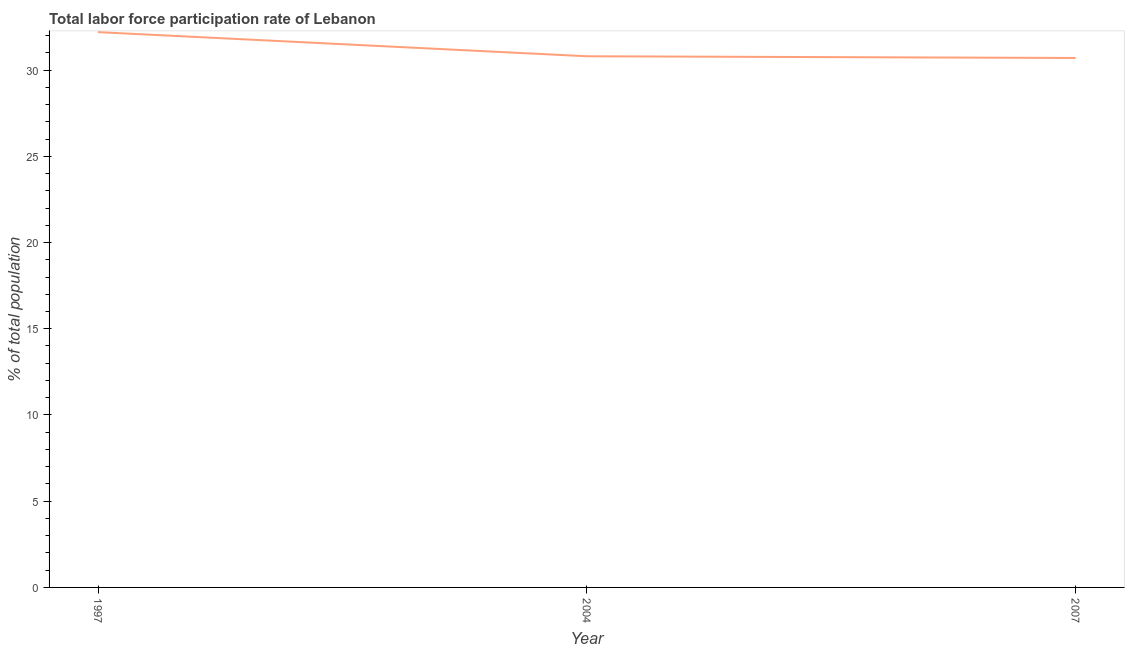What is the total labor force participation rate in 1997?
Provide a short and direct response. 32.2. Across all years, what is the maximum total labor force participation rate?
Your answer should be compact. 32.2. Across all years, what is the minimum total labor force participation rate?
Give a very brief answer. 30.7. In which year was the total labor force participation rate maximum?
Give a very brief answer. 1997. What is the sum of the total labor force participation rate?
Provide a succinct answer. 93.7. What is the difference between the total labor force participation rate in 2004 and 2007?
Make the answer very short. 0.1. What is the average total labor force participation rate per year?
Your answer should be very brief. 31.23. What is the median total labor force participation rate?
Your answer should be very brief. 30.8. In how many years, is the total labor force participation rate greater than 19 %?
Keep it short and to the point. 3. Do a majority of the years between 1997 and 2007 (inclusive) have total labor force participation rate greater than 25 %?
Your response must be concise. Yes. What is the ratio of the total labor force participation rate in 2004 to that in 2007?
Keep it short and to the point. 1. Is the total labor force participation rate in 2004 less than that in 2007?
Offer a very short reply. No. Is the difference between the total labor force participation rate in 2004 and 2007 greater than the difference between any two years?
Make the answer very short. No. What is the difference between the highest and the second highest total labor force participation rate?
Your answer should be very brief. 1.4. Is the sum of the total labor force participation rate in 1997 and 2007 greater than the maximum total labor force participation rate across all years?
Offer a very short reply. Yes. What is the difference between the highest and the lowest total labor force participation rate?
Your answer should be compact. 1.5. Does the total labor force participation rate monotonically increase over the years?
Provide a short and direct response. No. How many years are there in the graph?
Offer a very short reply. 3. What is the difference between two consecutive major ticks on the Y-axis?
Your answer should be very brief. 5. What is the title of the graph?
Make the answer very short. Total labor force participation rate of Lebanon. What is the label or title of the Y-axis?
Provide a succinct answer. % of total population. What is the % of total population in 1997?
Ensure brevity in your answer.  32.2. What is the % of total population of 2004?
Your answer should be very brief. 30.8. What is the % of total population of 2007?
Your response must be concise. 30.7. What is the difference between the % of total population in 2004 and 2007?
Provide a short and direct response. 0.1. What is the ratio of the % of total population in 1997 to that in 2004?
Offer a very short reply. 1.04. What is the ratio of the % of total population in 1997 to that in 2007?
Your answer should be compact. 1.05. What is the ratio of the % of total population in 2004 to that in 2007?
Provide a succinct answer. 1. 